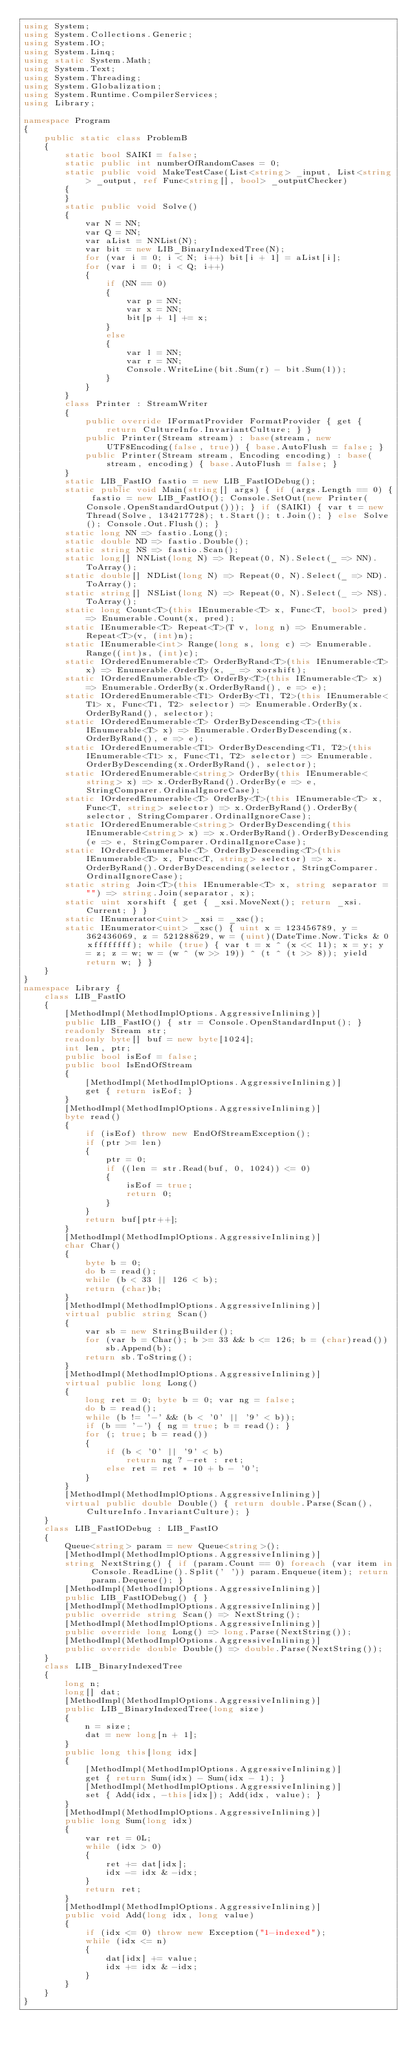<code> <loc_0><loc_0><loc_500><loc_500><_C#_>using System;
using System.Collections.Generic;
using System.IO;
using System.Linq;
using static System.Math;
using System.Text;
using System.Threading;
using System.Globalization;
using System.Runtime.CompilerServices;
using Library;

namespace Program
{
    public static class ProblemB
    {
        static bool SAIKI = false;
        static public int numberOfRandomCases = 0;
        static public void MakeTestCase(List<string> _input, List<string> _output, ref Func<string[], bool> _outputChecker)
        {
        }
        static public void Solve()
        {
            var N = NN;
            var Q = NN;
            var aList = NNList(N);
            var bit = new LIB_BinaryIndexedTree(N);
            for (var i = 0; i < N; i++) bit[i + 1] = aList[i];
            for (var i = 0; i < Q; i++)
            {
                if (NN == 0)
                {
                    var p = NN;
                    var x = NN;
                    bit[p + 1] += x;
                }
                else
                {
                    var l = NN;
                    var r = NN;
                    Console.WriteLine(bit.Sum(r) - bit.Sum(l));
                }
            }
        }
        class Printer : StreamWriter
        {
            public override IFormatProvider FormatProvider { get { return CultureInfo.InvariantCulture; } }
            public Printer(Stream stream) : base(stream, new UTF8Encoding(false, true)) { base.AutoFlush = false; }
            public Printer(Stream stream, Encoding encoding) : base(stream, encoding) { base.AutoFlush = false; }
        }
        static LIB_FastIO fastio = new LIB_FastIODebug();
        static public void Main(string[] args) { if (args.Length == 0) { fastio = new LIB_FastIO(); Console.SetOut(new Printer(Console.OpenStandardOutput())); } if (SAIKI) { var t = new Thread(Solve, 134217728); t.Start(); t.Join(); } else Solve(); Console.Out.Flush(); }
        static long NN => fastio.Long();
        static double ND => fastio.Double();
        static string NS => fastio.Scan();
        static long[] NNList(long N) => Repeat(0, N).Select(_ => NN).ToArray();
        static double[] NDList(long N) => Repeat(0, N).Select(_ => ND).ToArray();
        static string[] NSList(long N) => Repeat(0, N).Select(_ => NS).ToArray();
        static long Count<T>(this IEnumerable<T> x, Func<T, bool> pred) => Enumerable.Count(x, pred);
        static IEnumerable<T> Repeat<T>(T v, long n) => Enumerable.Repeat<T>(v, (int)n);
        static IEnumerable<int> Range(long s, long c) => Enumerable.Range((int)s, (int)c);
        static IOrderedEnumerable<T> OrderByRand<T>(this IEnumerable<T> x) => Enumerable.OrderBy(x, _ => xorshift);
        static IOrderedEnumerable<T> OrderBy<T>(this IEnumerable<T> x) => Enumerable.OrderBy(x.OrderByRand(), e => e);
        static IOrderedEnumerable<T1> OrderBy<T1, T2>(this IEnumerable<T1> x, Func<T1, T2> selector) => Enumerable.OrderBy(x.OrderByRand(), selector);
        static IOrderedEnumerable<T> OrderByDescending<T>(this IEnumerable<T> x) => Enumerable.OrderByDescending(x.OrderByRand(), e => e);
        static IOrderedEnumerable<T1> OrderByDescending<T1, T2>(this IEnumerable<T1> x, Func<T1, T2> selector) => Enumerable.OrderByDescending(x.OrderByRand(), selector);
        static IOrderedEnumerable<string> OrderBy(this IEnumerable<string> x) => x.OrderByRand().OrderBy(e => e, StringComparer.OrdinalIgnoreCase);
        static IOrderedEnumerable<T> OrderBy<T>(this IEnumerable<T> x, Func<T, string> selector) => x.OrderByRand().OrderBy(selector, StringComparer.OrdinalIgnoreCase);
        static IOrderedEnumerable<string> OrderByDescending(this IEnumerable<string> x) => x.OrderByRand().OrderByDescending(e => e, StringComparer.OrdinalIgnoreCase);
        static IOrderedEnumerable<T> OrderByDescending<T>(this IEnumerable<T> x, Func<T, string> selector) => x.OrderByRand().OrderByDescending(selector, StringComparer.OrdinalIgnoreCase);
        static string Join<T>(this IEnumerable<T> x, string separator = "") => string.Join(separator, x);
        static uint xorshift { get { _xsi.MoveNext(); return _xsi.Current; } }
        static IEnumerator<uint> _xsi = _xsc();
        static IEnumerator<uint> _xsc() { uint x = 123456789, y = 362436069, z = 521288629, w = (uint)(DateTime.Now.Ticks & 0xffffffff); while (true) { var t = x ^ (x << 11); x = y; y = z; z = w; w = (w ^ (w >> 19)) ^ (t ^ (t >> 8)); yield return w; } }
    }
}
namespace Library {
    class LIB_FastIO
    {
        [MethodImpl(MethodImplOptions.AggressiveInlining)]
        public LIB_FastIO() { str = Console.OpenStandardInput(); }
        readonly Stream str;
        readonly byte[] buf = new byte[1024];
        int len, ptr;
        public bool isEof = false;
        public bool IsEndOfStream
        {
            [MethodImpl(MethodImplOptions.AggressiveInlining)]
            get { return isEof; }
        }
        [MethodImpl(MethodImplOptions.AggressiveInlining)]
        byte read()
        {
            if (isEof) throw new EndOfStreamException();
            if (ptr >= len)
            {
                ptr = 0;
                if ((len = str.Read(buf, 0, 1024)) <= 0)
                {
                    isEof = true;
                    return 0;
                }
            }
            return buf[ptr++];
        }
        [MethodImpl(MethodImplOptions.AggressiveInlining)]
        char Char()
        {
            byte b = 0;
            do b = read();
            while (b < 33 || 126 < b);
            return (char)b;
        }
        [MethodImpl(MethodImplOptions.AggressiveInlining)]
        virtual public string Scan()
        {
            var sb = new StringBuilder();
            for (var b = Char(); b >= 33 && b <= 126; b = (char)read())
                sb.Append(b);
            return sb.ToString();
        }
        [MethodImpl(MethodImplOptions.AggressiveInlining)]
        virtual public long Long()
        {
            long ret = 0; byte b = 0; var ng = false;
            do b = read();
            while (b != '-' && (b < '0' || '9' < b));
            if (b == '-') { ng = true; b = read(); }
            for (; true; b = read())
            {
                if (b < '0' || '9' < b)
                    return ng ? -ret : ret;
                else ret = ret * 10 + b - '0';
            }
        }
        [MethodImpl(MethodImplOptions.AggressiveInlining)]
        virtual public double Double() { return double.Parse(Scan(), CultureInfo.InvariantCulture); }
    }
    class LIB_FastIODebug : LIB_FastIO
    {
        Queue<string> param = new Queue<string>();
        [MethodImpl(MethodImplOptions.AggressiveInlining)]
        string NextString() { if (param.Count == 0) foreach (var item in Console.ReadLine().Split(' ')) param.Enqueue(item); return param.Dequeue(); }
        [MethodImpl(MethodImplOptions.AggressiveInlining)]
        public LIB_FastIODebug() { }
        [MethodImpl(MethodImplOptions.AggressiveInlining)]
        public override string Scan() => NextString();
        [MethodImpl(MethodImplOptions.AggressiveInlining)]
        public override long Long() => long.Parse(NextString());
        [MethodImpl(MethodImplOptions.AggressiveInlining)]
        public override double Double() => double.Parse(NextString());
    }
    class LIB_BinaryIndexedTree
    {
        long n;
        long[] dat;
        [MethodImpl(MethodImplOptions.AggressiveInlining)]
        public LIB_BinaryIndexedTree(long size)
        {
            n = size;
            dat = new long[n + 1];
        }
        public long this[long idx]
        {
            [MethodImpl(MethodImplOptions.AggressiveInlining)]
            get { return Sum(idx) - Sum(idx - 1); }
            [MethodImpl(MethodImplOptions.AggressiveInlining)]
            set { Add(idx, -this[idx]); Add(idx, value); }
        }
        [MethodImpl(MethodImplOptions.AggressiveInlining)]
        public long Sum(long idx)
        {
            var ret = 0L;
            while (idx > 0)
            {
                ret += dat[idx];
                idx -= idx & -idx;
            }
            return ret;
        }
        [MethodImpl(MethodImplOptions.AggressiveInlining)]
        public void Add(long idx, long value)
        {
            if (idx <= 0) throw new Exception("1-indexed");
            while (idx <= n)
            {
                dat[idx] += value;
                idx += idx & -idx;
            }
        }
    }
}
</code> 